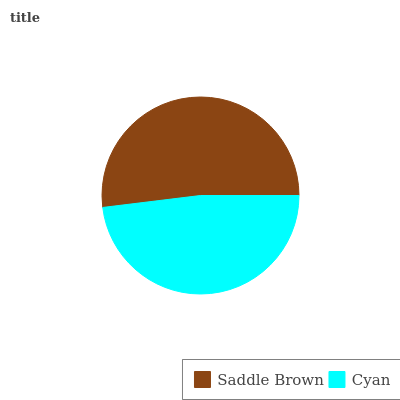Is Cyan the minimum?
Answer yes or no. Yes. Is Saddle Brown the maximum?
Answer yes or no. Yes. Is Cyan the maximum?
Answer yes or no. No. Is Saddle Brown greater than Cyan?
Answer yes or no. Yes. Is Cyan less than Saddle Brown?
Answer yes or no. Yes. Is Cyan greater than Saddle Brown?
Answer yes or no. No. Is Saddle Brown less than Cyan?
Answer yes or no. No. Is Saddle Brown the high median?
Answer yes or no. Yes. Is Cyan the low median?
Answer yes or no. Yes. Is Cyan the high median?
Answer yes or no. No. Is Saddle Brown the low median?
Answer yes or no. No. 